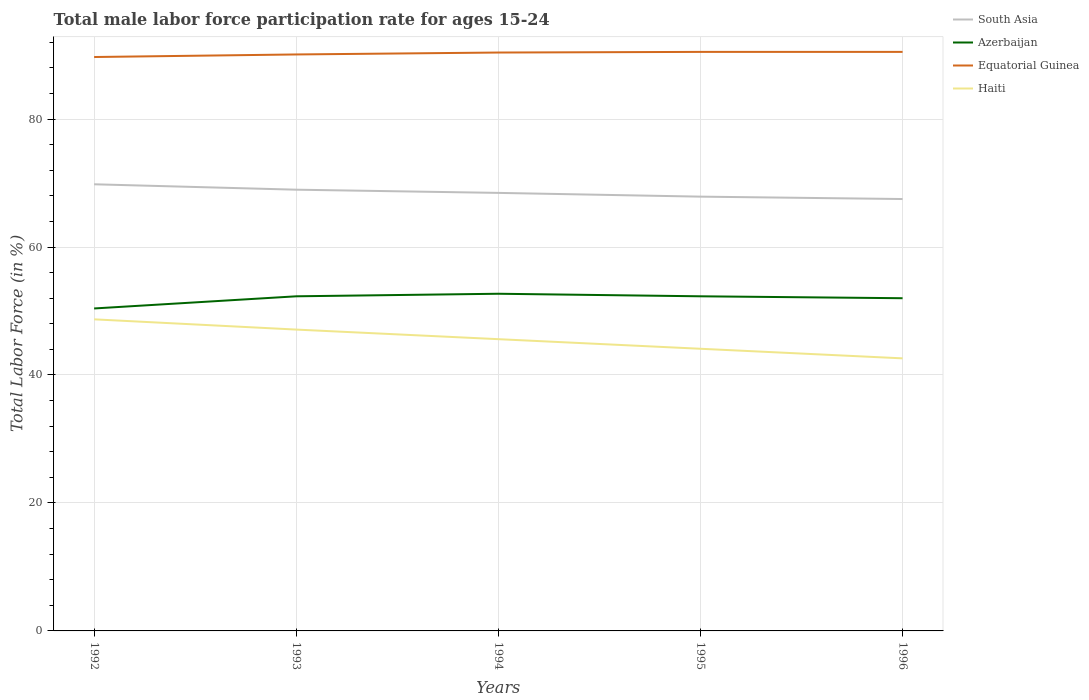Across all years, what is the maximum male labor force participation rate in Equatorial Guinea?
Ensure brevity in your answer.  89.7. What is the total male labor force participation rate in Azerbaijan in the graph?
Offer a terse response. 0.4. What is the difference between the highest and the second highest male labor force participation rate in Haiti?
Keep it short and to the point. 6.1. What is the difference between the highest and the lowest male labor force participation rate in Azerbaijan?
Your answer should be compact. 4. How many years are there in the graph?
Your answer should be very brief. 5. Does the graph contain grids?
Provide a succinct answer. Yes. What is the title of the graph?
Provide a succinct answer. Total male labor force participation rate for ages 15-24. Does "South Asia" appear as one of the legend labels in the graph?
Offer a terse response. Yes. What is the label or title of the X-axis?
Offer a terse response. Years. What is the Total Labor Force (in %) of South Asia in 1992?
Your answer should be compact. 69.81. What is the Total Labor Force (in %) of Azerbaijan in 1992?
Make the answer very short. 50.4. What is the Total Labor Force (in %) of Equatorial Guinea in 1992?
Provide a succinct answer. 89.7. What is the Total Labor Force (in %) in Haiti in 1992?
Give a very brief answer. 48.7. What is the Total Labor Force (in %) of South Asia in 1993?
Offer a very short reply. 68.96. What is the Total Labor Force (in %) in Azerbaijan in 1993?
Make the answer very short. 52.3. What is the Total Labor Force (in %) in Equatorial Guinea in 1993?
Make the answer very short. 90.1. What is the Total Labor Force (in %) of Haiti in 1993?
Offer a terse response. 47.1. What is the Total Labor Force (in %) in South Asia in 1994?
Keep it short and to the point. 68.46. What is the Total Labor Force (in %) of Azerbaijan in 1994?
Offer a terse response. 52.7. What is the Total Labor Force (in %) of Equatorial Guinea in 1994?
Ensure brevity in your answer.  90.4. What is the Total Labor Force (in %) in Haiti in 1994?
Provide a succinct answer. 45.6. What is the Total Labor Force (in %) of South Asia in 1995?
Make the answer very short. 67.88. What is the Total Labor Force (in %) in Azerbaijan in 1995?
Your response must be concise. 52.3. What is the Total Labor Force (in %) of Equatorial Guinea in 1995?
Provide a short and direct response. 90.5. What is the Total Labor Force (in %) in Haiti in 1995?
Your response must be concise. 44.1. What is the Total Labor Force (in %) of South Asia in 1996?
Provide a short and direct response. 67.5. What is the Total Labor Force (in %) of Equatorial Guinea in 1996?
Ensure brevity in your answer.  90.5. What is the Total Labor Force (in %) in Haiti in 1996?
Provide a short and direct response. 42.6. Across all years, what is the maximum Total Labor Force (in %) in South Asia?
Your answer should be very brief. 69.81. Across all years, what is the maximum Total Labor Force (in %) in Azerbaijan?
Provide a succinct answer. 52.7. Across all years, what is the maximum Total Labor Force (in %) in Equatorial Guinea?
Offer a very short reply. 90.5. Across all years, what is the maximum Total Labor Force (in %) of Haiti?
Give a very brief answer. 48.7. Across all years, what is the minimum Total Labor Force (in %) in South Asia?
Your answer should be very brief. 67.5. Across all years, what is the minimum Total Labor Force (in %) in Azerbaijan?
Ensure brevity in your answer.  50.4. Across all years, what is the minimum Total Labor Force (in %) of Equatorial Guinea?
Offer a very short reply. 89.7. Across all years, what is the minimum Total Labor Force (in %) in Haiti?
Offer a terse response. 42.6. What is the total Total Labor Force (in %) in South Asia in the graph?
Keep it short and to the point. 342.62. What is the total Total Labor Force (in %) of Azerbaijan in the graph?
Give a very brief answer. 259.7. What is the total Total Labor Force (in %) in Equatorial Guinea in the graph?
Provide a short and direct response. 451.2. What is the total Total Labor Force (in %) in Haiti in the graph?
Make the answer very short. 228.1. What is the difference between the Total Labor Force (in %) of South Asia in 1992 and that in 1993?
Make the answer very short. 0.85. What is the difference between the Total Labor Force (in %) in South Asia in 1992 and that in 1994?
Offer a very short reply. 1.35. What is the difference between the Total Labor Force (in %) in Azerbaijan in 1992 and that in 1994?
Ensure brevity in your answer.  -2.3. What is the difference between the Total Labor Force (in %) in Equatorial Guinea in 1992 and that in 1994?
Your answer should be very brief. -0.7. What is the difference between the Total Labor Force (in %) of South Asia in 1992 and that in 1995?
Give a very brief answer. 1.93. What is the difference between the Total Labor Force (in %) of Azerbaijan in 1992 and that in 1995?
Give a very brief answer. -1.9. What is the difference between the Total Labor Force (in %) in Equatorial Guinea in 1992 and that in 1995?
Your response must be concise. -0.8. What is the difference between the Total Labor Force (in %) of South Asia in 1992 and that in 1996?
Provide a succinct answer. 2.3. What is the difference between the Total Labor Force (in %) in Azerbaijan in 1992 and that in 1996?
Ensure brevity in your answer.  -1.6. What is the difference between the Total Labor Force (in %) of South Asia in 1993 and that in 1994?
Offer a very short reply. 0.5. What is the difference between the Total Labor Force (in %) in Azerbaijan in 1993 and that in 1994?
Ensure brevity in your answer.  -0.4. What is the difference between the Total Labor Force (in %) in Haiti in 1993 and that in 1994?
Your answer should be very brief. 1.5. What is the difference between the Total Labor Force (in %) of South Asia in 1993 and that in 1995?
Provide a short and direct response. 1.09. What is the difference between the Total Labor Force (in %) of Azerbaijan in 1993 and that in 1995?
Offer a very short reply. 0. What is the difference between the Total Labor Force (in %) in South Asia in 1993 and that in 1996?
Keep it short and to the point. 1.46. What is the difference between the Total Labor Force (in %) in Equatorial Guinea in 1993 and that in 1996?
Keep it short and to the point. -0.4. What is the difference between the Total Labor Force (in %) in Haiti in 1993 and that in 1996?
Offer a terse response. 4.5. What is the difference between the Total Labor Force (in %) of South Asia in 1994 and that in 1995?
Offer a terse response. 0.58. What is the difference between the Total Labor Force (in %) in Haiti in 1994 and that in 1995?
Make the answer very short. 1.5. What is the difference between the Total Labor Force (in %) of South Asia in 1994 and that in 1996?
Your answer should be compact. 0.96. What is the difference between the Total Labor Force (in %) of Azerbaijan in 1994 and that in 1996?
Keep it short and to the point. 0.7. What is the difference between the Total Labor Force (in %) of Haiti in 1994 and that in 1996?
Offer a very short reply. 3. What is the difference between the Total Labor Force (in %) in South Asia in 1995 and that in 1996?
Offer a terse response. 0.37. What is the difference between the Total Labor Force (in %) in Azerbaijan in 1995 and that in 1996?
Your response must be concise. 0.3. What is the difference between the Total Labor Force (in %) in Haiti in 1995 and that in 1996?
Give a very brief answer. 1.5. What is the difference between the Total Labor Force (in %) of South Asia in 1992 and the Total Labor Force (in %) of Azerbaijan in 1993?
Keep it short and to the point. 17.51. What is the difference between the Total Labor Force (in %) of South Asia in 1992 and the Total Labor Force (in %) of Equatorial Guinea in 1993?
Your response must be concise. -20.29. What is the difference between the Total Labor Force (in %) of South Asia in 1992 and the Total Labor Force (in %) of Haiti in 1993?
Offer a very short reply. 22.71. What is the difference between the Total Labor Force (in %) of Azerbaijan in 1992 and the Total Labor Force (in %) of Equatorial Guinea in 1993?
Offer a terse response. -39.7. What is the difference between the Total Labor Force (in %) in Azerbaijan in 1992 and the Total Labor Force (in %) in Haiti in 1993?
Ensure brevity in your answer.  3.3. What is the difference between the Total Labor Force (in %) in Equatorial Guinea in 1992 and the Total Labor Force (in %) in Haiti in 1993?
Offer a terse response. 42.6. What is the difference between the Total Labor Force (in %) in South Asia in 1992 and the Total Labor Force (in %) in Azerbaijan in 1994?
Make the answer very short. 17.11. What is the difference between the Total Labor Force (in %) of South Asia in 1992 and the Total Labor Force (in %) of Equatorial Guinea in 1994?
Provide a succinct answer. -20.59. What is the difference between the Total Labor Force (in %) in South Asia in 1992 and the Total Labor Force (in %) in Haiti in 1994?
Keep it short and to the point. 24.21. What is the difference between the Total Labor Force (in %) in Azerbaijan in 1992 and the Total Labor Force (in %) in Haiti in 1994?
Your answer should be very brief. 4.8. What is the difference between the Total Labor Force (in %) in Equatorial Guinea in 1992 and the Total Labor Force (in %) in Haiti in 1994?
Ensure brevity in your answer.  44.1. What is the difference between the Total Labor Force (in %) of South Asia in 1992 and the Total Labor Force (in %) of Azerbaijan in 1995?
Provide a short and direct response. 17.51. What is the difference between the Total Labor Force (in %) of South Asia in 1992 and the Total Labor Force (in %) of Equatorial Guinea in 1995?
Ensure brevity in your answer.  -20.69. What is the difference between the Total Labor Force (in %) in South Asia in 1992 and the Total Labor Force (in %) in Haiti in 1995?
Your answer should be very brief. 25.71. What is the difference between the Total Labor Force (in %) in Azerbaijan in 1992 and the Total Labor Force (in %) in Equatorial Guinea in 1995?
Provide a succinct answer. -40.1. What is the difference between the Total Labor Force (in %) in Equatorial Guinea in 1992 and the Total Labor Force (in %) in Haiti in 1995?
Your answer should be very brief. 45.6. What is the difference between the Total Labor Force (in %) of South Asia in 1992 and the Total Labor Force (in %) of Azerbaijan in 1996?
Give a very brief answer. 17.81. What is the difference between the Total Labor Force (in %) in South Asia in 1992 and the Total Labor Force (in %) in Equatorial Guinea in 1996?
Your response must be concise. -20.69. What is the difference between the Total Labor Force (in %) of South Asia in 1992 and the Total Labor Force (in %) of Haiti in 1996?
Provide a short and direct response. 27.21. What is the difference between the Total Labor Force (in %) in Azerbaijan in 1992 and the Total Labor Force (in %) in Equatorial Guinea in 1996?
Offer a terse response. -40.1. What is the difference between the Total Labor Force (in %) of Equatorial Guinea in 1992 and the Total Labor Force (in %) of Haiti in 1996?
Offer a terse response. 47.1. What is the difference between the Total Labor Force (in %) of South Asia in 1993 and the Total Labor Force (in %) of Azerbaijan in 1994?
Provide a succinct answer. 16.26. What is the difference between the Total Labor Force (in %) in South Asia in 1993 and the Total Labor Force (in %) in Equatorial Guinea in 1994?
Give a very brief answer. -21.44. What is the difference between the Total Labor Force (in %) in South Asia in 1993 and the Total Labor Force (in %) in Haiti in 1994?
Your response must be concise. 23.36. What is the difference between the Total Labor Force (in %) of Azerbaijan in 1993 and the Total Labor Force (in %) of Equatorial Guinea in 1994?
Make the answer very short. -38.1. What is the difference between the Total Labor Force (in %) of Equatorial Guinea in 1993 and the Total Labor Force (in %) of Haiti in 1994?
Provide a succinct answer. 44.5. What is the difference between the Total Labor Force (in %) in South Asia in 1993 and the Total Labor Force (in %) in Azerbaijan in 1995?
Offer a very short reply. 16.66. What is the difference between the Total Labor Force (in %) in South Asia in 1993 and the Total Labor Force (in %) in Equatorial Guinea in 1995?
Make the answer very short. -21.54. What is the difference between the Total Labor Force (in %) of South Asia in 1993 and the Total Labor Force (in %) of Haiti in 1995?
Provide a succinct answer. 24.86. What is the difference between the Total Labor Force (in %) in Azerbaijan in 1993 and the Total Labor Force (in %) in Equatorial Guinea in 1995?
Provide a succinct answer. -38.2. What is the difference between the Total Labor Force (in %) in Azerbaijan in 1993 and the Total Labor Force (in %) in Haiti in 1995?
Offer a terse response. 8.2. What is the difference between the Total Labor Force (in %) in South Asia in 1993 and the Total Labor Force (in %) in Azerbaijan in 1996?
Your response must be concise. 16.96. What is the difference between the Total Labor Force (in %) of South Asia in 1993 and the Total Labor Force (in %) of Equatorial Guinea in 1996?
Offer a very short reply. -21.54. What is the difference between the Total Labor Force (in %) of South Asia in 1993 and the Total Labor Force (in %) of Haiti in 1996?
Your response must be concise. 26.36. What is the difference between the Total Labor Force (in %) of Azerbaijan in 1993 and the Total Labor Force (in %) of Equatorial Guinea in 1996?
Offer a very short reply. -38.2. What is the difference between the Total Labor Force (in %) of Equatorial Guinea in 1993 and the Total Labor Force (in %) of Haiti in 1996?
Offer a very short reply. 47.5. What is the difference between the Total Labor Force (in %) in South Asia in 1994 and the Total Labor Force (in %) in Azerbaijan in 1995?
Ensure brevity in your answer.  16.16. What is the difference between the Total Labor Force (in %) of South Asia in 1994 and the Total Labor Force (in %) of Equatorial Guinea in 1995?
Ensure brevity in your answer.  -22.04. What is the difference between the Total Labor Force (in %) of South Asia in 1994 and the Total Labor Force (in %) of Haiti in 1995?
Your answer should be very brief. 24.36. What is the difference between the Total Labor Force (in %) of Azerbaijan in 1994 and the Total Labor Force (in %) of Equatorial Guinea in 1995?
Your response must be concise. -37.8. What is the difference between the Total Labor Force (in %) in Equatorial Guinea in 1994 and the Total Labor Force (in %) in Haiti in 1995?
Ensure brevity in your answer.  46.3. What is the difference between the Total Labor Force (in %) of South Asia in 1994 and the Total Labor Force (in %) of Azerbaijan in 1996?
Offer a very short reply. 16.46. What is the difference between the Total Labor Force (in %) of South Asia in 1994 and the Total Labor Force (in %) of Equatorial Guinea in 1996?
Provide a short and direct response. -22.04. What is the difference between the Total Labor Force (in %) of South Asia in 1994 and the Total Labor Force (in %) of Haiti in 1996?
Make the answer very short. 25.86. What is the difference between the Total Labor Force (in %) in Azerbaijan in 1994 and the Total Labor Force (in %) in Equatorial Guinea in 1996?
Keep it short and to the point. -37.8. What is the difference between the Total Labor Force (in %) of Azerbaijan in 1994 and the Total Labor Force (in %) of Haiti in 1996?
Your answer should be very brief. 10.1. What is the difference between the Total Labor Force (in %) of Equatorial Guinea in 1994 and the Total Labor Force (in %) of Haiti in 1996?
Offer a very short reply. 47.8. What is the difference between the Total Labor Force (in %) in South Asia in 1995 and the Total Labor Force (in %) in Azerbaijan in 1996?
Offer a very short reply. 15.88. What is the difference between the Total Labor Force (in %) in South Asia in 1995 and the Total Labor Force (in %) in Equatorial Guinea in 1996?
Your answer should be very brief. -22.62. What is the difference between the Total Labor Force (in %) in South Asia in 1995 and the Total Labor Force (in %) in Haiti in 1996?
Provide a succinct answer. 25.28. What is the difference between the Total Labor Force (in %) of Azerbaijan in 1995 and the Total Labor Force (in %) of Equatorial Guinea in 1996?
Provide a short and direct response. -38.2. What is the difference between the Total Labor Force (in %) in Equatorial Guinea in 1995 and the Total Labor Force (in %) in Haiti in 1996?
Offer a terse response. 47.9. What is the average Total Labor Force (in %) of South Asia per year?
Provide a short and direct response. 68.52. What is the average Total Labor Force (in %) in Azerbaijan per year?
Make the answer very short. 51.94. What is the average Total Labor Force (in %) in Equatorial Guinea per year?
Offer a very short reply. 90.24. What is the average Total Labor Force (in %) in Haiti per year?
Provide a short and direct response. 45.62. In the year 1992, what is the difference between the Total Labor Force (in %) of South Asia and Total Labor Force (in %) of Azerbaijan?
Offer a terse response. 19.41. In the year 1992, what is the difference between the Total Labor Force (in %) in South Asia and Total Labor Force (in %) in Equatorial Guinea?
Provide a succinct answer. -19.89. In the year 1992, what is the difference between the Total Labor Force (in %) in South Asia and Total Labor Force (in %) in Haiti?
Make the answer very short. 21.11. In the year 1992, what is the difference between the Total Labor Force (in %) of Azerbaijan and Total Labor Force (in %) of Equatorial Guinea?
Keep it short and to the point. -39.3. In the year 1992, what is the difference between the Total Labor Force (in %) of Azerbaijan and Total Labor Force (in %) of Haiti?
Offer a very short reply. 1.7. In the year 1993, what is the difference between the Total Labor Force (in %) in South Asia and Total Labor Force (in %) in Azerbaijan?
Your answer should be compact. 16.66. In the year 1993, what is the difference between the Total Labor Force (in %) in South Asia and Total Labor Force (in %) in Equatorial Guinea?
Make the answer very short. -21.14. In the year 1993, what is the difference between the Total Labor Force (in %) in South Asia and Total Labor Force (in %) in Haiti?
Provide a succinct answer. 21.86. In the year 1993, what is the difference between the Total Labor Force (in %) in Azerbaijan and Total Labor Force (in %) in Equatorial Guinea?
Your answer should be very brief. -37.8. In the year 1993, what is the difference between the Total Labor Force (in %) in Equatorial Guinea and Total Labor Force (in %) in Haiti?
Offer a very short reply. 43. In the year 1994, what is the difference between the Total Labor Force (in %) of South Asia and Total Labor Force (in %) of Azerbaijan?
Your answer should be compact. 15.76. In the year 1994, what is the difference between the Total Labor Force (in %) of South Asia and Total Labor Force (in %) of Equatorial Guinea?
Your response must be concise. -21.94. In the year 1994, what is the difference between the Total Labor Force (in %) in South Asia and Total Labor Force (in %) in Haiti?
Your answer should be compact. 22.86. In the year 1994, what is the difference between the Total Labor Force (in %) of Azerbaijan and Total Labor Force (in %) of Equatorial Guinea?
Offer a terse response. -37.7. In the year 1994, what is the difference between the Total Labor Force (in %) of Equatorial Guinea and Total Labor Force (in %) of Haiti?
Your answer should be very brief. 44.8. In the year 1995, what is the difference between the Total Labor Force (in %) in South Asia and Total Labor Force (in %) in Azerbaijan?
Provide a short and direct response. 15.58. In the year 1995, what is the difference between the Total Labor Force (in %) of South Asia and Total Labor Force (in %) of Equatorial Guinea?
Offer a terse response. -22.62. In the year 1995, what is the difference between the Total Labor Force (in %) of South Asia and Total Labor Force (in %) of Haiti?
Offer a terse response. 23.78. In the year 1995, what is the difference between the Total Labor Force (in %) in Azerbaijan and Total Labor Force (in %) in Equatorial Guinea?
Keep it short and to the point. -38.2. In the year 1995, what is the difference between the Total Labor Force (in %) in Equatorial Guinea and Total Labor Force (in %) in Haiti?
Make the answer very short. 46.4. In the year 1996, what is the difference between the Total Labor Force (in %) in South Asia and Total Labor Force (in %) in Azerbaijan?
Offer a very short reply. 15.5. In the year 1996, what is the difference between the Total Labor Force (in %) of South Asia and Total Labor Force (in %) of Equatorial Guinea?
Your answer should be compact. -23. In the year 1996, what is the difference between the Total Labor Force (in %) of South Asia and Total Labor Force (in %) of Haiti?
Keep it short and to the point. 24.9. In the year 1996, what is the difference between the Total Labor Force (in %) in Azerbaijan and Total Labor Force (in %) in Equatorial Guinea?
Keep it short and to the point. -38.5. In the year 1996, what is the difference between the Total Labor Force (in %) of Azerbaijan and Total Labor Force (in %) of Haiti?
Offer a very short reply. 9.4. In the year 1996, what is the difference between the Total Labor Force (in %) of Equatorial Guinea and Total Labor Force (in %) of Haiti?
Keep it short and to the point. 47.9. What is the ratio of the Total Labor Force (in %) of South Asia in 1992 to that in 1993?
Your answer should be compact. 1.01. What is the ratio of the Total Labor Force (in %) in Azerbaijan in 1992 to that in 1993?
Offer a very short reply. 0.96. What is the ratio of the Total Labor Force (in %) of Equatorial Guinea in 1992 to that in 1993?
Give a very brief answer. 1. What is the ratio of the Total Labor Force (in %) of Haiti in 1992 to that in 1993?
Give a very brief answer. 1.03. What is the ratio of the Total Labor Force (in %) of South Asia in 1992 to that in 1994?
Offer a terse response. 1.02. What is the ratio of the Total Labor Force (in %) in Azerbaijan in 1992 to that in 1994?
Your answer should be very brief. 0.96. What is the ratio of the Total Labor Force (in %) in Equatorial Guinea in 1992 to that in 1994?
Ensure brevity in your answer.  0.99. What is the ratio of the Total Labor Force (in %) of Haiti in 1992 to that in 1994?
Give a very brief answer. 1.07. What is the ratio of the Total Labor Force (in %) in South Asia in 1992 to that in 1995?
Ensure brevity in your answer.  1.03. What is the ratio of the Total Labor Force (in %) in Azerbaijan in 1992 to that in 1995?
Your response must be concise. 0.96. What is the ratio of the Total Labor Force (in %) in Equatorial Guinea in 1992 to that in 1995?
Your response must be concise. 0.99. What is the ratio of the Total Labor Force (in %) of Haiti in 1992 to that in 1995?
Your response must be concise. 1.1. What is the ratio of the Total Labor Force (in %) of South Asia in 1992 to that in 1996?
Offer a terse response. 1.03. What is the ratio of the Total Labor Force (in %) of Azerbaijan in 1992 to that in 1996?
Offer a terse response. 0.97. What is the ratio of the Total Labor Force (in %) of Equatorial Guinea in 1992 to that in 1996?
Your answer should be compact. 0.99. What is the ratio of the Total Labor Force (in %) of Haiti in 1992 to that in 1996?
Keep it short and to the point. 1.14. What is the ratio of the Total Labor Force (in %) in South Asia in 1993 to that in 1994?
Keep it short and to the point. 1.01. What is the ratio of the Total Labor Force (in %) in Azerbaijan in 1993 to that in 1994?
Provide a short and direct response. 0.99. What is the ratio of the Total Labor Force (in %) in Haiti in 1993 to that in 1994?
Make the answer very short. 1.03. What is the ratio of the Total Labor Force (in %) in Azerbaijan in 1993 to that in 1995?
Offer a very short reply. 1. What is the ratio of the Total Labor Force (in %) of Haiti in 1993 to that in 1995?
Your answer should be very brief. 1.07. What is the ratio of the Total Labor Force (in %) of South Asia in 1993 to that in 1996?
Provide a short and direct response. 1.02. What is the ratio of the Total Labor Force (in %) of Azerbaijan in 1993 to that in 1996?
Provide a succinct answer. 1.01. What is the ratio of the Total Labor Force (in %) of Haiti in 1993 to that in 1996?
Give a very brief answer. 1.11. What is the ratio of the Total Labor Force (in %) of South Asia in 1994 to that in 1995?
Provide a short and direct response. 1.01. What is the ratio of the Total Labor Force (in %) in Azerbaijan in 1994 to that in 1995?
Keep it short and to the point. 1.01. What is the ratio of the Total Labor Force (in %) in Haiti in 1994 to that in 1995?
Give a very brief answer. 1.03. What is the ratio of the Total Labor Force (in %) of South Asia in 1994 to that in 1996?
Provide a succinct answer. 1.01. What is the ratio of the Total Labor Force (in %) in Azerbaijan in 1994 to that in 1996?
Give a very brief answer. 1.01. What is the ratio of the Total Labor Force (in %) in Haiti in 1994 to that in 1996?
Your answer should be very brief. 1.07. What is the ratio of the Total Labor Force (in %) of South Asia in 1995 to that in 1996?
Give a very brief answer. 1.01. What is the ratio of the Total Labor Force (in %) in Azerbaijan in 1995 to that in 1996?
Provide a succinct answer. 1.01. What is the ratio of the Total Labor Force (in %) in Haiti in 1995 to that in 1996?
Provide a succinct answer. 1.04. What is the difference between the highest and the second highest Total Labor Force (in %) in South Asia?
Give a very brief answer. 0.85. What is the difference between the highest and the lowest Total Labor Force (in %) in South Asia?
Offer a very short reply. 2.3. What is the difference between the highest and the lowest Total Labor Force (in %) of Haiti?
Your answer should be compact. 6.1. 